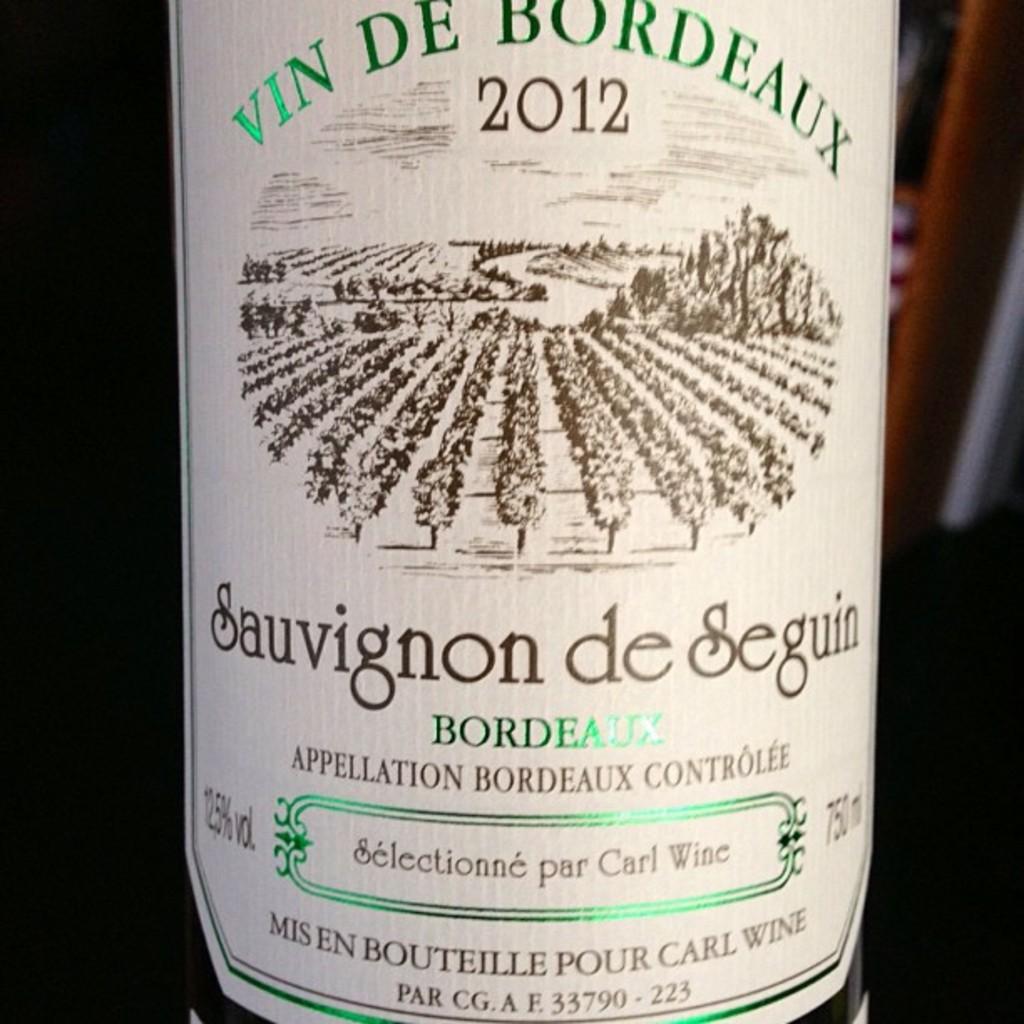What is the name of this wine?
Provide a succinct answer. Sauvignon de seguin. 